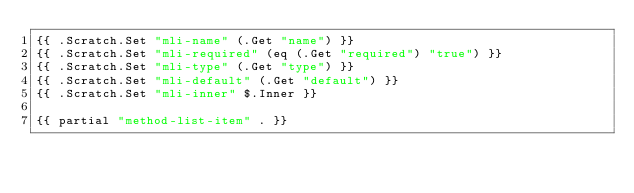Convert code to text. <code><loc_0><loc_0><loc_500><loc_500><_HTML_>{{ .Scratch.Set "mli-name" (.Get "name") }}
{{ .Scratch.Set "mli-required" (eq (.Get "required") "true") }}
{{ .Scratch.Set "mli-type" (.Get "type") }}
{{ .Scratch.Set "mli-default" (.Get "default") }}
{{ .Scratch.Set "mli-inner" $.Inner }}

{{ partial "method-list-item" . }}
</code> 